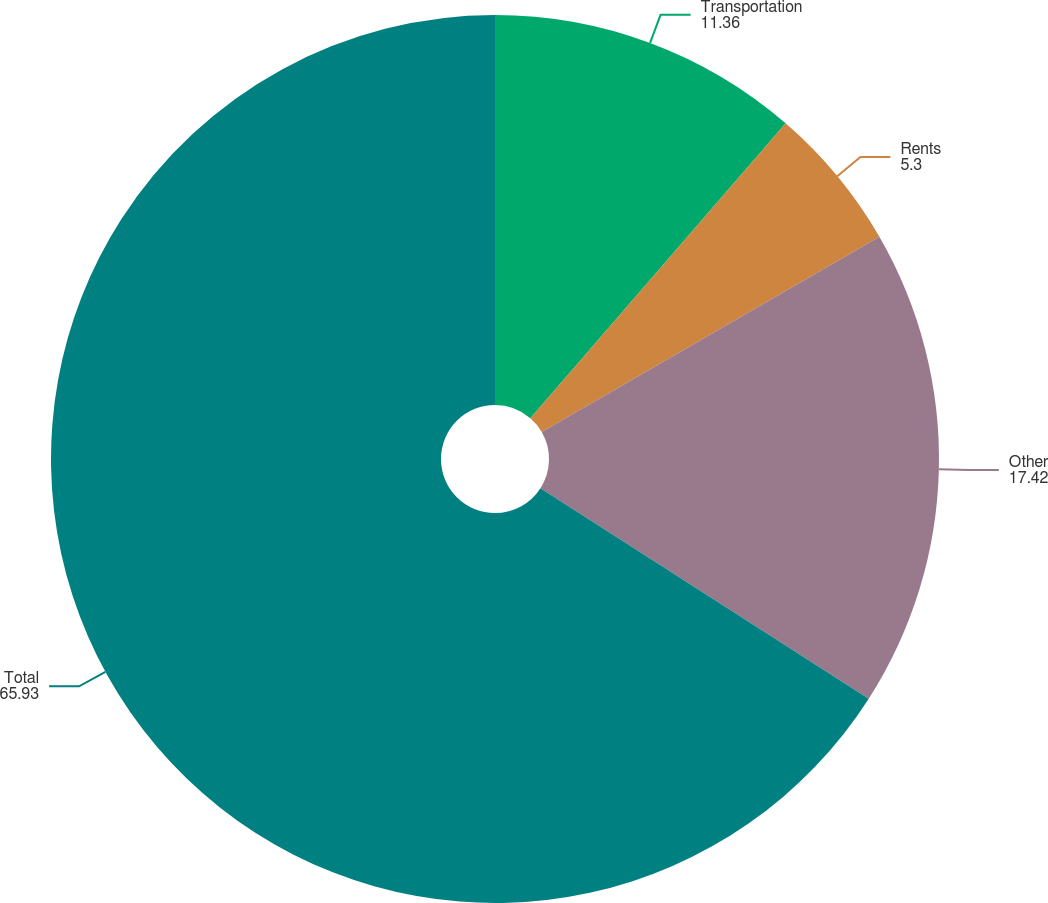Convert chart to OTSL. <chart><loc_0><loc_0><loc_500><loc_500><pie_chart><fcel>Transportation<fcel>Rents<fcel>Other<fcel>Total<nl><fcel>11.36%<fcel>5.3%<fcel>17.42%<fcel>65.93%<nl></chart> 